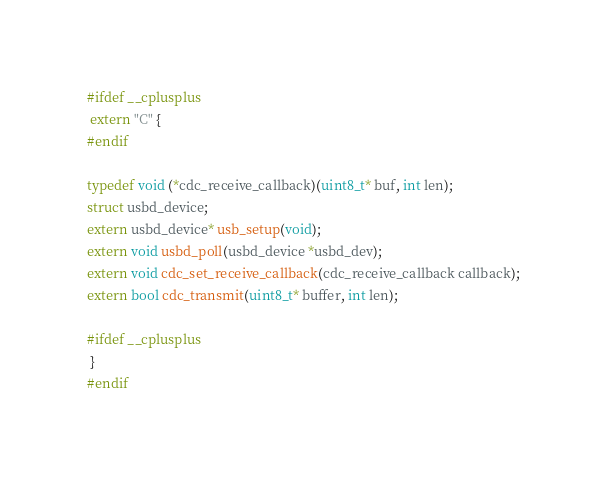Convert code to text. <code><loc_0><loc_0><loc_500><loc_500><_C_>#ifdef __cplusplus
 extern "C" {
#endif

typedef void (*cdc_receive_callback)(uint8_t* buf, int len);
struct usbd_device;
extern usbd_device* usb_setup(void);
extern void usbd_poll(usbd_device *usbd_dev);
extern void cdc_set_receive_callback(cdc_receive_callback callback);
extern bool cdc_transmit(uint8_t* buffer, int len);

#ifdef __cplusplus
 }
#endif
</code> 